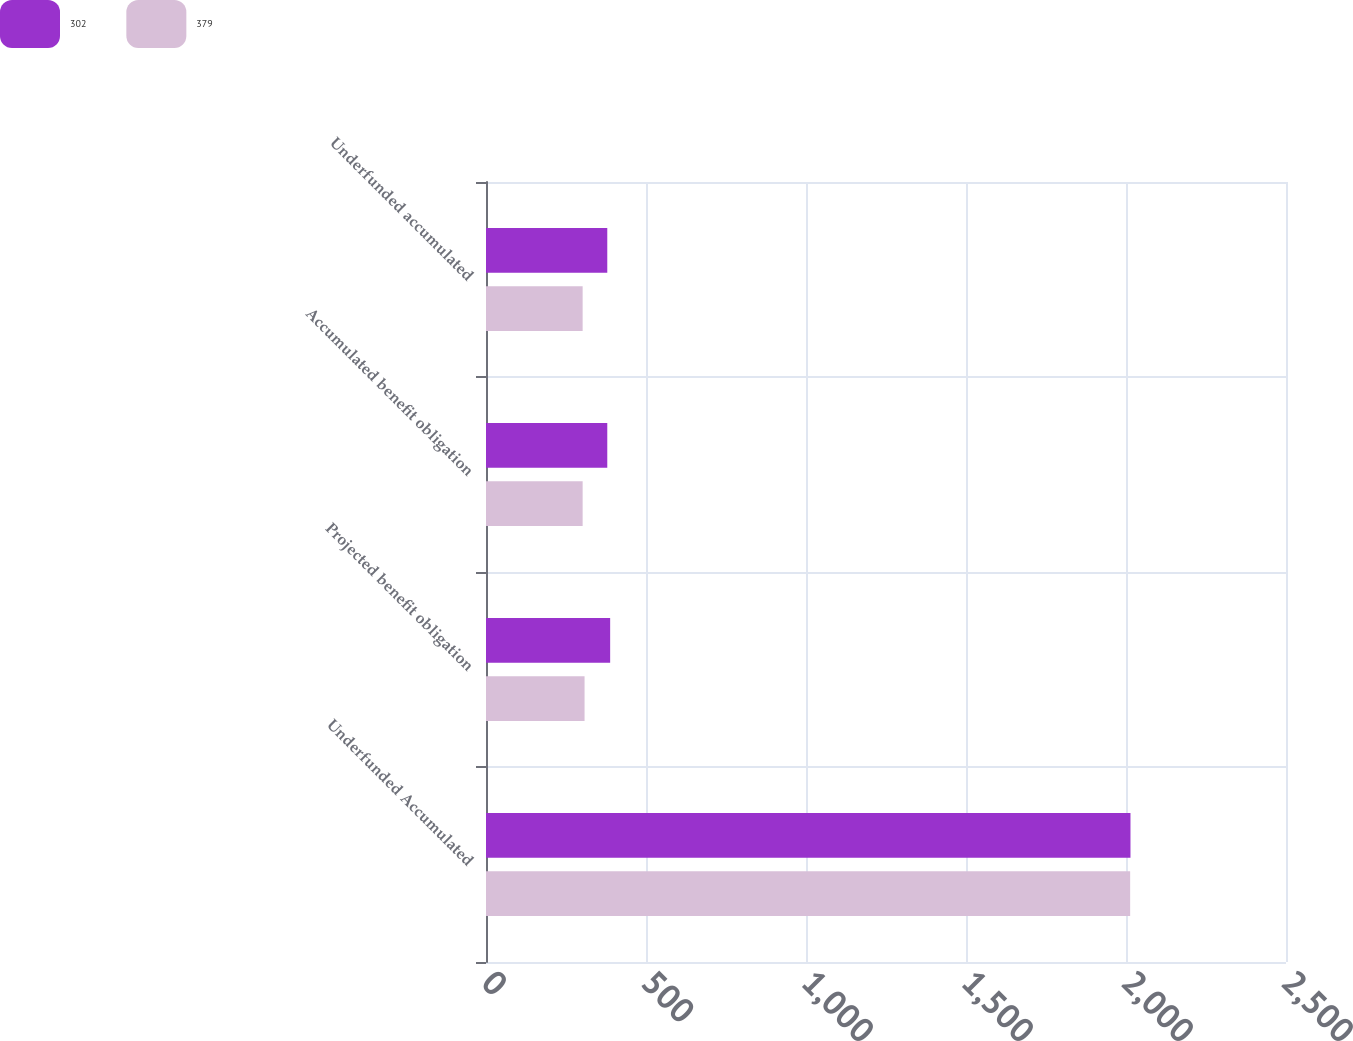<chart> <loc_0><loc_0><loc_500><loc_500><stacked_bar_chart><ecel><fcel>Underfunded Accumulated<fcel>Projected benefit obligation<fcel>Accumulated benefit obligation<fcel>Underfunded accumulated<nl><fcel>302<fcel>2014<fcel>388<fcel>379<fcel>379<nl><fcel>379<fcel>2013<fcel>308<fcel>302<fcel>302<nl></chart> 